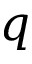Convert formula to latex. <formula><loc_0><loc_0><loc_500><loc_500>q</formula> 